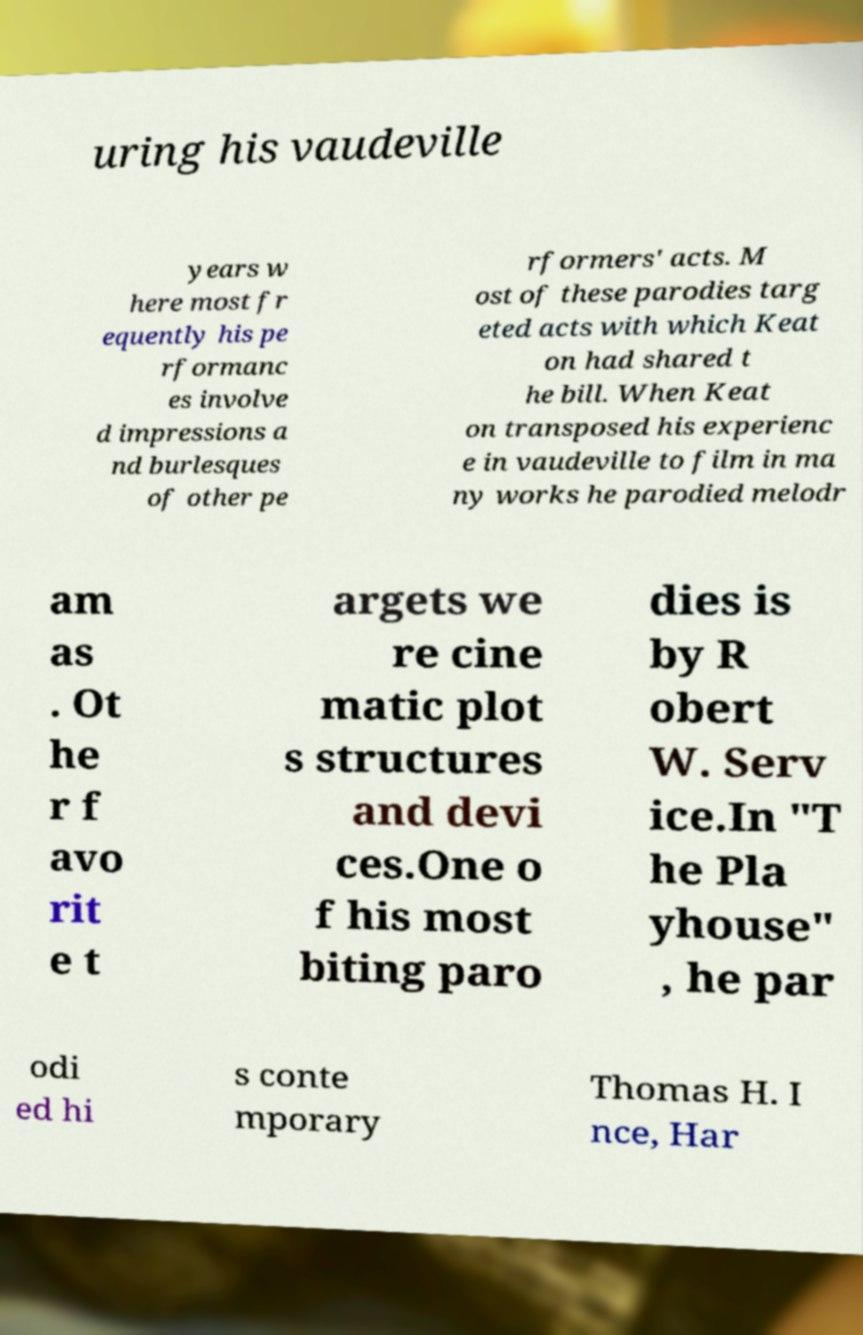What messages or text are displayed in this image? I need them in a readable, typed format. uring his vaudeville years w here most fr equently his pe rformanc es involve d impressions a nd burlesques of other pe rformers' acts. M ost of these parodies targ eted acts with which Keat on had shared t he bill. When Keat on transposed his experienc e in vaudeville to film in ma ny works he parodied melodr am as . Ot he r f avo rit e t argets we re cine matic plot s structures and devi ces.One o f his most biting paro dies is by R obert W. Serv ice.In "T he Pla yhouse" , he par odi ed hi s conte mporary Thomas H. I nce, Har 